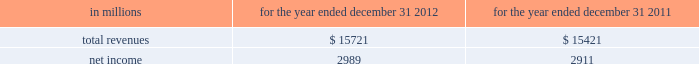See note 10 goodwill and other intangible assets for further discussion of the accounting for goodwill and other intangible assets .
The estimated amount of rbc bank ( usa ) revenue and net income ( excluding integration costs ) included in pnc 2019s consolidated income statement for 2012 was $ 1.0 billion and $ 273 million , respectively .
Upon closing and conversion of the rbc bank ( usa ) transaction , subsequent to march 2 , 2012 , separate records for rbc bank ( usa ) as a stand-alone business have not been maintained as the operations of rbc bank ( usa ) have been fully integrated into pnc .
Rbc bank ( usa ) revenue and earnings disclosed above reflect management 2019s best estimate , based on information available at the reporting date .
The table presents certain unaudited pro forma information for illustrative purposes only , for 2012 and 2011 as if rbc bank ( usa ) had been acquired on january 1 , 2011 .
The unaudited estimated pro forma information combines the historical results of rbc bank ( usa ) with the company 2019s consolidated historical results and includes certain adjustments reflecting the estimated impact of certain fair value adjustments for the respective periods .
The pro forma information is not indicative of what would have occurred had the acquisition taken place on january 1 , 2011 .
In particular , no adjustments have been made to eliminate the impact of other-than-temporary impairment losses and losses recognized on the sale of securities that may not have been necessary had the investment securities been recorded at fair value as of january 1 , 2011 .
The unaudited pro forma information does not consider any changes to the provision for credit losses resulting from recording loan assets at fair value .
Additionally , the pro forma financial information does not include the impact of possible business model changes and does not reflect pro forma adjustments to conform accounting policies between rbc bank ( usa ) and pnc .
Additionally , pnc expects to achieve further operating cost savings and other business synergies , including revenue growth , as a result of the acquisition that are not reflected in the pro forma amounts that follow .
As a result , actual results will differ from the unaudited pro forma information presented .
Table 57 : rbc bank ( usa ) and pnc unaudited pro forma results .
In connection with the rbc bank ( usa ) acquisition and other prior acquisitions , pnc recognized $ 267 million of integration charges in 2012 .
Pnc recognized $ 42 million of integration charges in 2011 in connection with prior acquisitions .
The integration charges are included in the table above .
Sale of smartstreet effective october 26 , 2012 , pnc divested certain deposits and assets of the smartstreet business unit , which was acquired by pnc as part of the rbc bank ( usa ) acquisition , to union bank , n.a .
Smartstreet is a nationwide business focused on homeowner or community association managers and had approximately $ 1 billion of assets and deposits as of september 30 , 2012 .
The gain on sale was immaterial and resulted in a reduction of goodwill and core deposit intangibles of $ 46 million and $ 13 million , respectively .
Results from operations of smartstreet from march 2 , 2012 through october 26 , 2012 are included in our consolidated income statement .
Flagstar branch acquisition effective december 9 , 2011 , pnc acquired 27 branches in the northern metropolitan atlanta , georgia area from flagstar bank , fsb , a subsidiary of flagstar bancorp , inc .
The fair value of the assets acquired totaled approximately $ 211.8 million , including $ 169.3 million in cash , $ 24.3 million in fixed assets and $ 18.2 million of goodwill and intangible assets .
We also assumed approximately $ 210.5 million of deposits associated with these branches .
No deposit premium was paid and no loans were acquired in the transaction .
Our consolidated income statement includes the impact of the branch activity subsequent to our december 9 , 2011 acquisition .
Bankatlantic branch acquisition effective june 6 , 2011 , we acquired 19 branches in the greater tampa , florida area from bankatlantic , a subsidiary of bankatlantic bancorp , inc .
The fair value of the assets acquired totaled $ 324.9 million , including $ 256.9 million in cash , $ 26.0 million in fixed assets and $ 42.0 million of goodwill and intangible assets .
We also assumed approximately $ 324.5 million of deposits associated with these branches .
A $ 39.0 million deposit premium was paid and no loans were acquired in the transaction .
Our consolidated income statement includes the impact of the branch activity subsequent to our june 6 , 2011 acquisition .
Sale of pnc global investment servicing on july 1 , 2010 , we sold pnc global investment servicing inc .
( gis ) , a leading provider of processing , technology and business intelligence services to asset managers , broker- dealers and financial advisors worldwide , for $ 2.3 billion in cash pursuant to a definitive agreement entered into on february 2 , 2010 .
This transaction resulted in a pretax gain of $ 639 million , net of transaction costs , in the third quarter of 2010 .
This gain and results of operations of gis through june 30 , 2010 are presented as income from discontinued operations , net of income taxes , on our consolidated income statement .
As part of the sale agreement , pnc has agreed to provide certain transitional services on behalf of gis until completion of related systems conversion activities .
138 the pnc financial services group , inc .
2013 form 10-k .
What was the average , in millions , of pnc's total recognized integration charges from 2011-2012? 
Computations: ((267 + 42) / 2)
Answer: 154.5. 